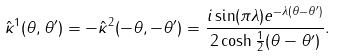<formula> <loc_0><loc_0><loc_500><loc_500>\hat { \kappa } ^ { 1 } ( \theta , \theta ^ { \prime } ) = - \hat { \kappa } ^ { 2 } ( - \theta , - \theta ^ { \prime } ) = \frac { i \sin ( \pi \lambda ) e ^ { - \lambda ( \theta - \theta ^ { \prime } ) } } { 2 \cosh \frac { 1 } { 2 } ( \theta - \theta ^ { \prime } ) } .</formula> 